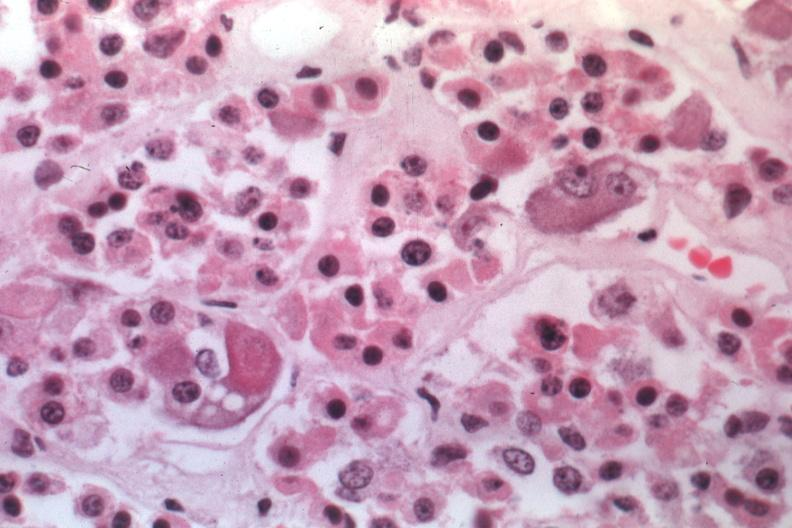s pituitary present?
Answer the question using a single word or phrase. Yes 